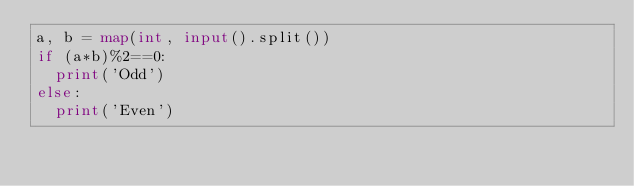Convert code to text. <code><loc_0><loc_0><loc_500><loc_500><_Python_>a, b = map(int, input().split())
if (a*b)%2==0:
  print('Odd')
else:
  print('Even')</code> 